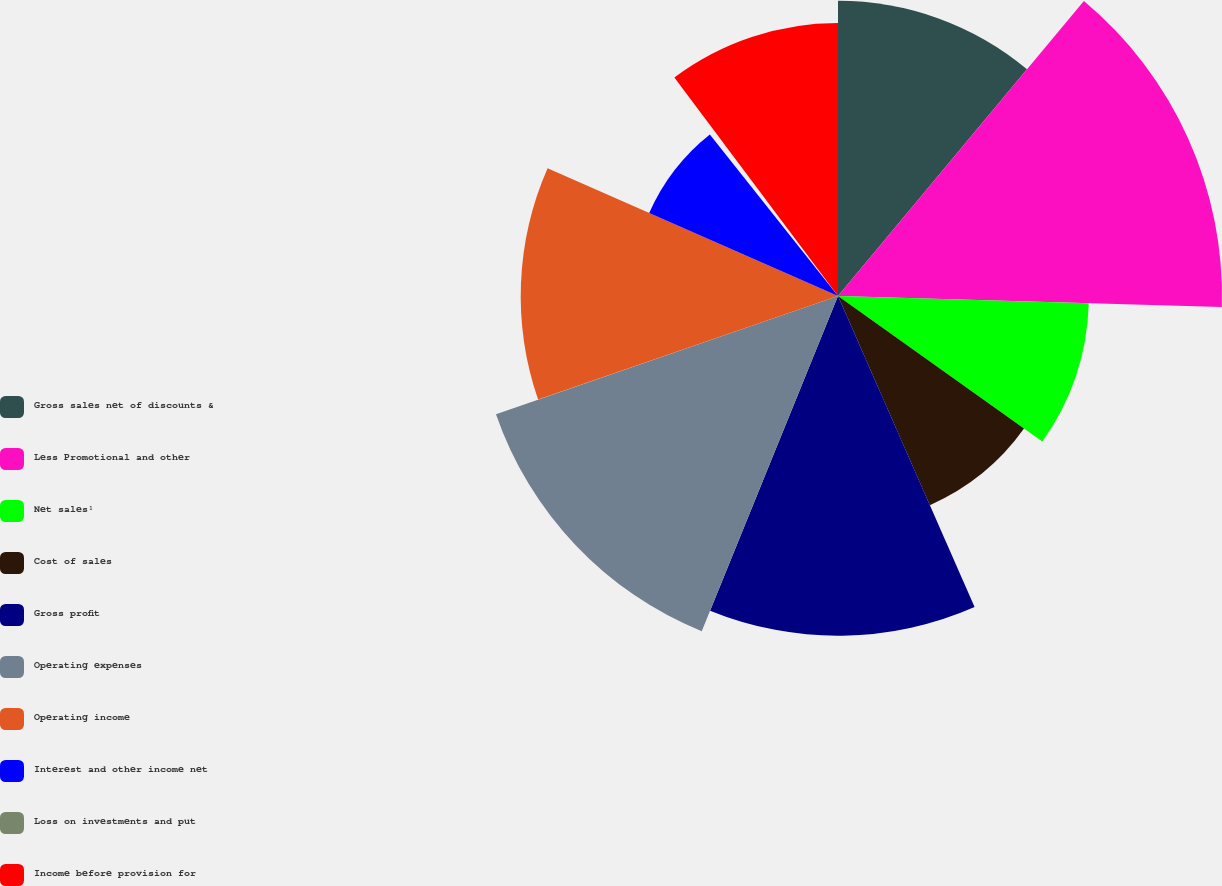Convert chart to OTSL. <chart><loc_0><loc_0><loc_500><loc_500><pie_chart><fcel>Gross sales net of discounts &<fcel>Less Promotional and other<fcel>Net sales¹<fcel>Cost of sales<fcel>Gross profit<fcel>Operating expenses<fcel>Operating income<fcel>Interest and other income net<fcel>Loss on investments and put<fcel>Income before provision for<nl><fcel>11.06%<fcel>14.39%<fcel>9.4%<fcel>8.56%<fcel>12.73%<fcel>13.56%<fcel>11.89%<fcel>7.73%<fcel>0.44%<fcel>10.23%<nl></chart> 